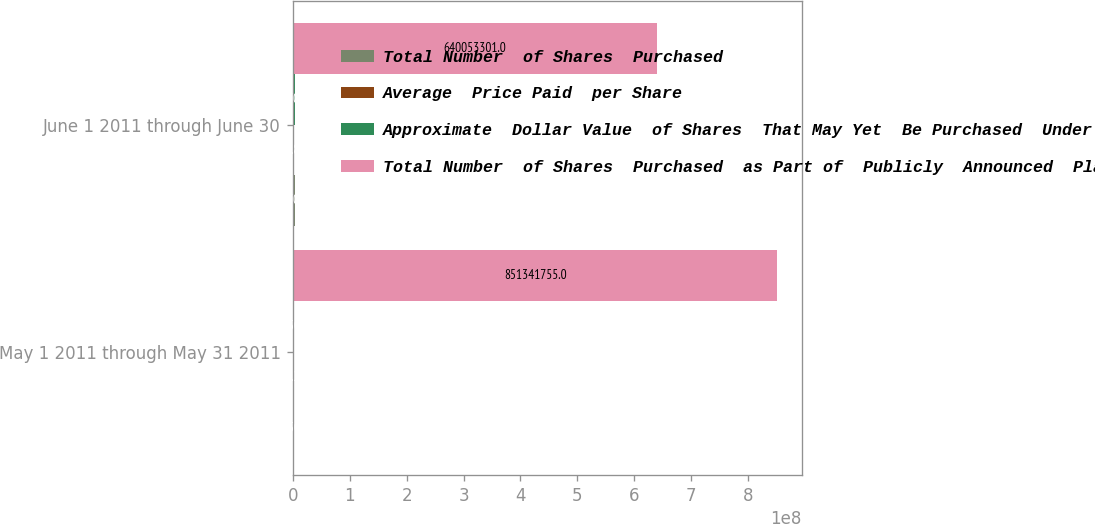Convert chart to OTSL. <chart><loc_0><loc_0><loc_500><loc_500><stacked_bar_chart><ecel><fcel>May 1 2011 through May 31 2011<fcel>June 1 2011 through June 30<nl><fcel>Total Number  of Shares  Purchased<fcel>727500<fcel>4.1571e+06<nl><fcel>Average  Price Paid  per Share<fcel>53.21<fcel>50.83<nl><fcel>Approximate  Dollar Value  of Shares  That May Yet  Be Purchased  Under  the Plans<fcel>727500<fcel>4.1571e+06<nl><fcel>Total Number  of Shares  Purchased  as Part of  Publicly  Announced  Plans<fcel>8.51342e+08<fcel>6.40053e+08<nl></chart> 